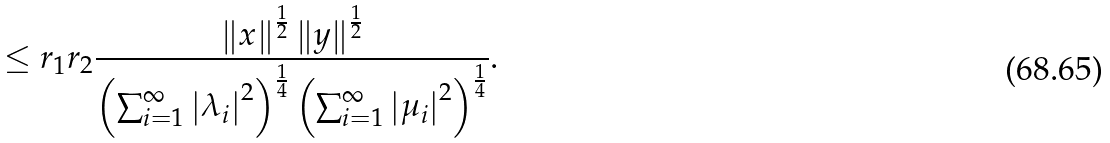<formula> <loc_0><loc_0><loc_500><loc_500>\leq r _ { 1 } r _ { 2 } \frac { \left \| x \right \| ^ { \frac { 1 } { 2 } } \left \| y \right \| ^ { \frac { 1 } { 2 } } } { \left ( \sum _ { i = 1 } ^ { \infty } \left | \lambda _ { i } \right | ^ { 2 } \right ) ^ { \frac { 1 } { 4 } } \left ( \sum _ { i = 1 } ^ { \infty } \left | \mu _ { i } \right | ^ { 2 } \right ) ^ { \frac { 1 } { 4 } } } .</formula> 